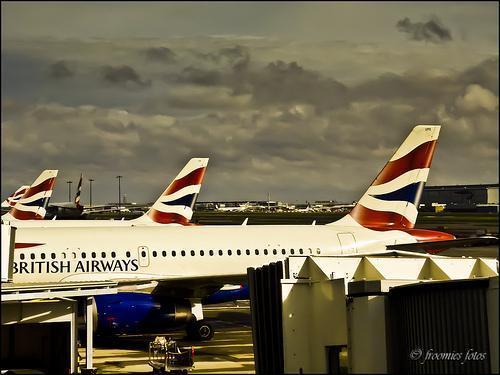How many airplane rudders can be seen?
Give a very brief answer. 5. 